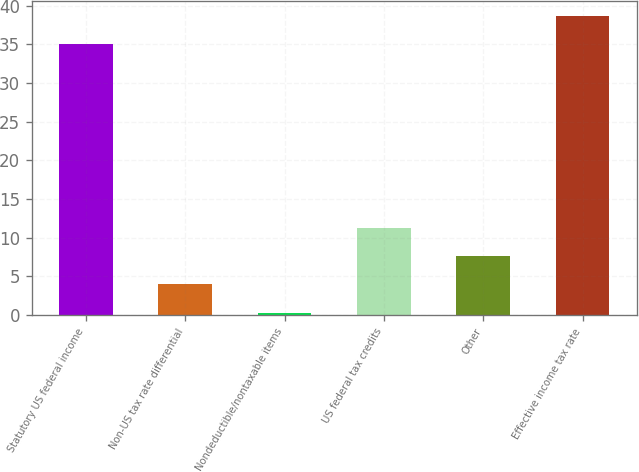Convert chart to OTSL. <chart><loc_0><loc_0><loc_500><loc_500><bar_chart><fcel>Statutory US federal income<fcel>Non-US tax rate differential<fcel>Nondeductible/nontaxable items<fcel>US federal tax credits<fcel>Other<fcel>Effective income tax rate<nl><fcel>35<fcel>3.96<fcel>0.3<fcel>11.28<fcel>7.62<fcel>38.66<nl></chart> 